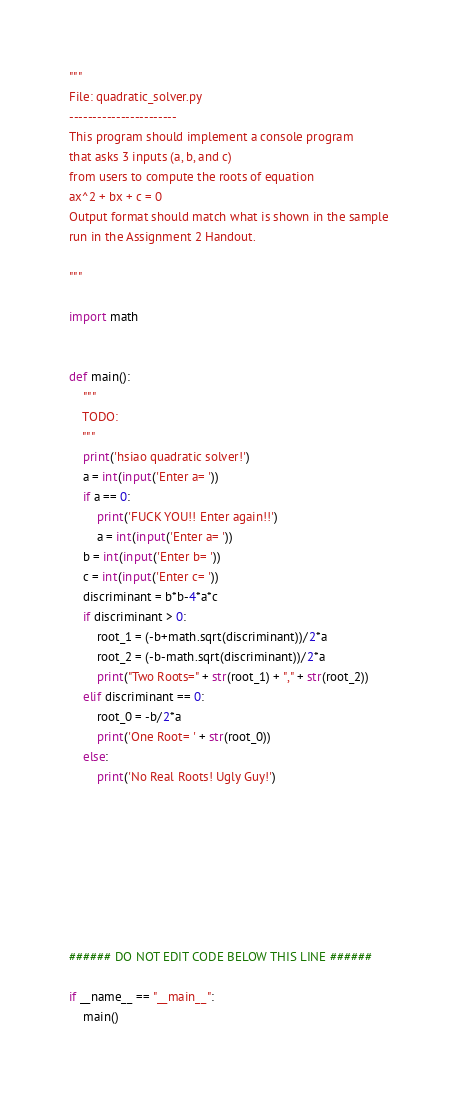Convert code to text. <code><loc_0><loc_0><loc_500><loc_500><_Python_>"""
File: quadratic_solver.py
-----------------------
This program should implement a console program
that asks 3 inputs (a, b, and c)
from users to compute the roots of equation
ax^2 + bx + c = 0
Output format should match what is shown in the sample
run in the Assignment 2 Handout.

"""

import math


def main():
	"""
	TODO:
	"""
	print('hsiao quadratic solver!')
	a = int(input('Enter a= '))
	if a == 0:
		print('FUCK YOU!! Enter again!!')
		a = int(input('Enter a= '))
	b = int(input('Enter b= '))
	c = int(input('Enter c= '))
	discriminant = b*b-4*a*c
	if discriminant > 0:
		root_1 = (-b+math.sqrt(discriminant))/2*a
		root_2 = (-b-math.sqrt(discriminant))/2*a
		print("Two Roots=" + str(root_1) + "," + str(root_2))
	elif discriminant == 0:
		root_0 = -b/2*a
		print('One Root= ' + str(root_0))
	else:
		print('No Real Roots! Ugly Guy!')








###### DO NOT EDIT CODE BELOW THIS LINE ######

if __name__ == "__main__":
	main()
</code> 